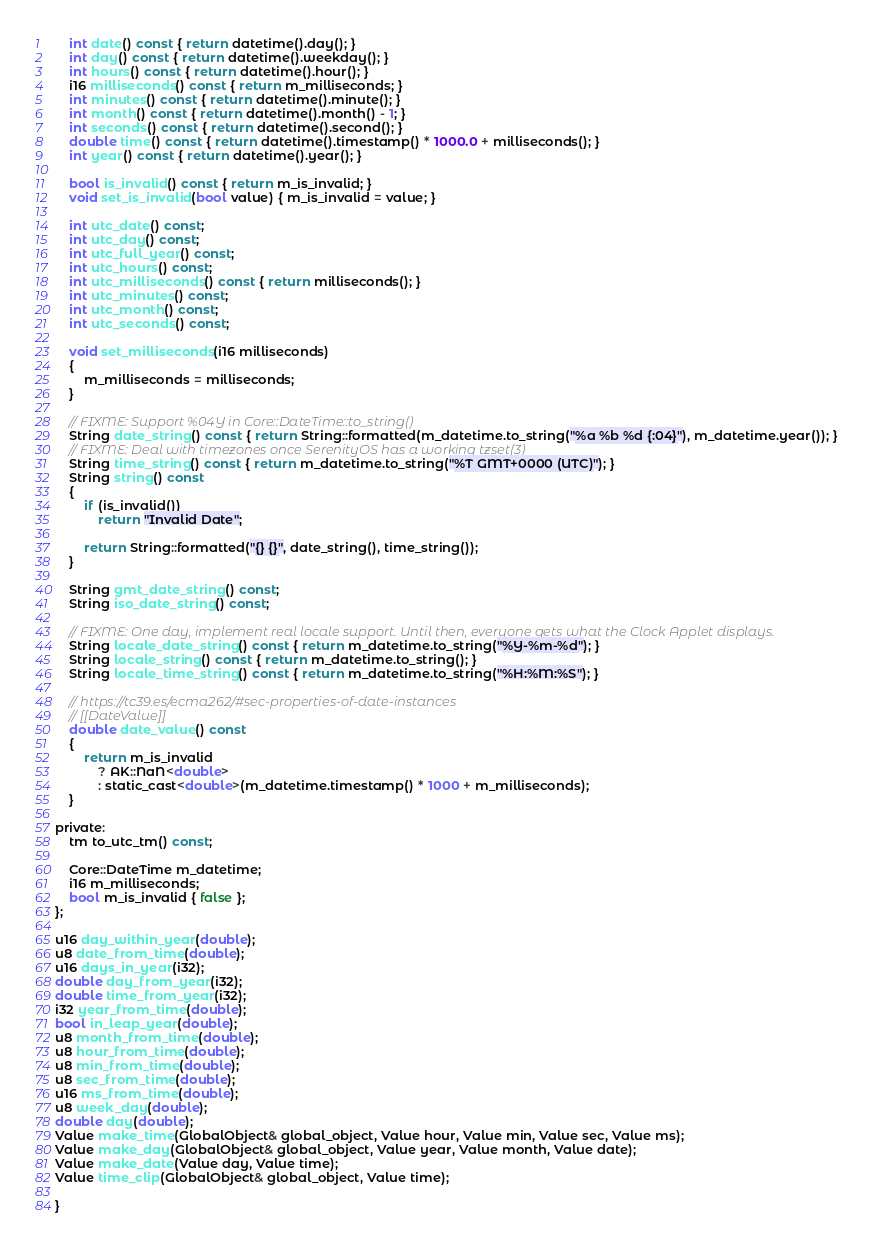Convert code to text. <code><loc_0><loc_0><loc_500><loc_500><_C_>    int date() const { return datetime().day(); }
    int day() const { return datetime().weekday(); }
    int hours() const { return datetime().hour(); }
    i16 milliseconds() const { return m_milliseconds; }
    int minutes() const { return datetime().minute(); }
    int month() const { return datetime().month() - 1; }
    int seconds() const { return datetime().second(); }
    double time() const { return datetime().timestamp() * 1000.0 + milliseconds(); }
    int year() const { return datetime().year(); }

    bool is_invalid() const { return m_is_invalid; }
    void set_is_invalid(bool value) { m_is_invalid = value; }

    int utc_date() const;
    int utc_day() const;
    int utc_full_year() const;
    int utc_hours() const;
    int utc_milliseconds() const { return milliseconds(); }
    int utc_minutes() const;
    int utc_month() const;
    int utc_seconds() const;

    void set_milliseconds(i16 milliseconds)
    {
        m_milliseconds = milliseconds;
    }

    // FIXME: Support %04Y in Core::DateTime::to_string()
    String date_string() const { return String::formatted(m_datetime.to_string("%a %b %d {:04}"), m_datetime.year()); }
    // FIXME: Deal with timezones once SerenityOS has a working tzset(3)
    String time_string() const { return m_datetime.to_string("%T GMT+0000 (UTC)"); }
    String string() const
    {
        if (is_invalid())
            return "Invalid Date";

        return String::formatted("{} {}", date_string(), time_string());
    }

    String gmt_date_string() const;
    String iso_date_string() const;

    // FIXME: One day, implement real locale support. Until then, everyone gets what the Clock Applet displays.
    String locale_date_string() const { return m_datetime.to_string("%Y-%m-%d"); }
    String locale_string() const { return m_datetime.to_string(); }
    String locale_time_string() const { return m_datetime.to_string("%H:%M:%S"); }

    // https://tc39.es/ecma262/#sec-properties-of-date-instances
    // [[DateValue]]
    double date_value() const
    {
        return m_is_invalid
            ? AK::NaN<double>
            : static_cast<double>(m_datetime.timestamp() * 1000 + m_milliseconds);
    }

private:
    tm to_utc_tm() const;

    Core::DateTime m_datetime;
    i16 m_milliseconds;
    bool m_is_invalid { false };
};

u16 day_within_year(double);
u8 date_from_time(double);
u16 days_in_year(i32);
double day_from_year(i32);
double time_from_year(i32);
i32 year_from_time(double);
bool in_leap_year(double);
u8 month_from_time(double);
u8 hour_from_time(double);
u8 min_from_time(double);
u8 sec_from_time(double);
u16 ms_from_time(double);
u8 week_day(double);
double day(double);
Value make_time(GlobalObject& global_object, Value hour, Value min, Value sec, Value ms);
Value make_day(GlobalObject& global_object, Value year, Value month, Value date);
Value make_date(Value day, Value time);
Value time_clip(GlobalObject& global_object, Value time);

}
</code> 